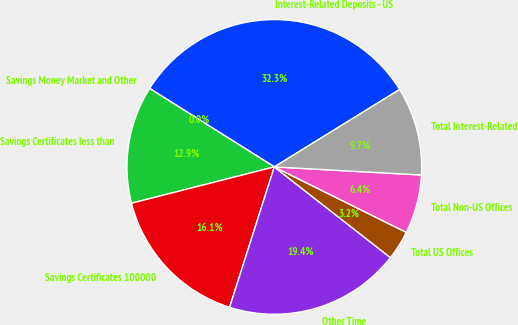Convert chart. <chart><loc_0><loc_0><loc_500><loc_500><pie_chart><fcel>Interest-Related Deposits - US<fcel>Savings Money Market and Other<fcel>Savings Certificates less than<fcel>Savings Certificates 100000<fcel>Other Time<fcel>Total US Offices<fcel>Total Non-US Offices<fcel>Total Interest-Related<nl><fcel>32.26%<fcel>0.0%<fcel>12.9%<fcel>16.13%<fcel>19.35%<fcel>3.23%<fcel>6.45%<fcel>9.68%<nl></chart> 